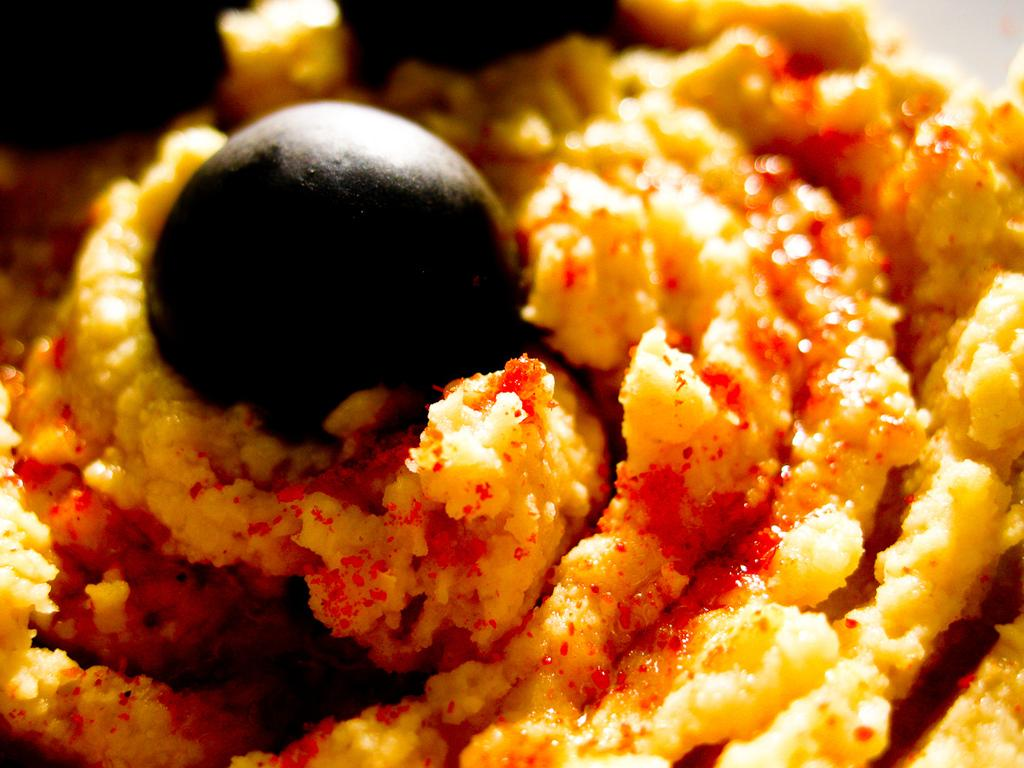What types of items can be seen in the image? There are food items in the image. Can you describe the appearance of the food items? The food items have visible ingredients. Where is the nearest market to the location of the food items in the image? The provided facts do not give any information about the location of the food items or the nearest market, so it cannot be determined from the image. 